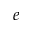Convert formula to latex. <formula><loc_0><loc_0><loc_500><loc_500>e</formula> 